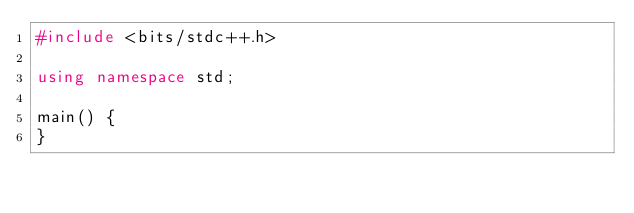<code> <loc_0><loc_0><loc_500><loc_500><_C++_>#include <bits/stdc++.h>

using namespace std;

main() {
}</code> 